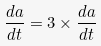<formula> <loc_0><loc_0><loc_500><loc_500>\frac { d a } { d t } = 3 \times \frac { d a } { d t }</formula> 